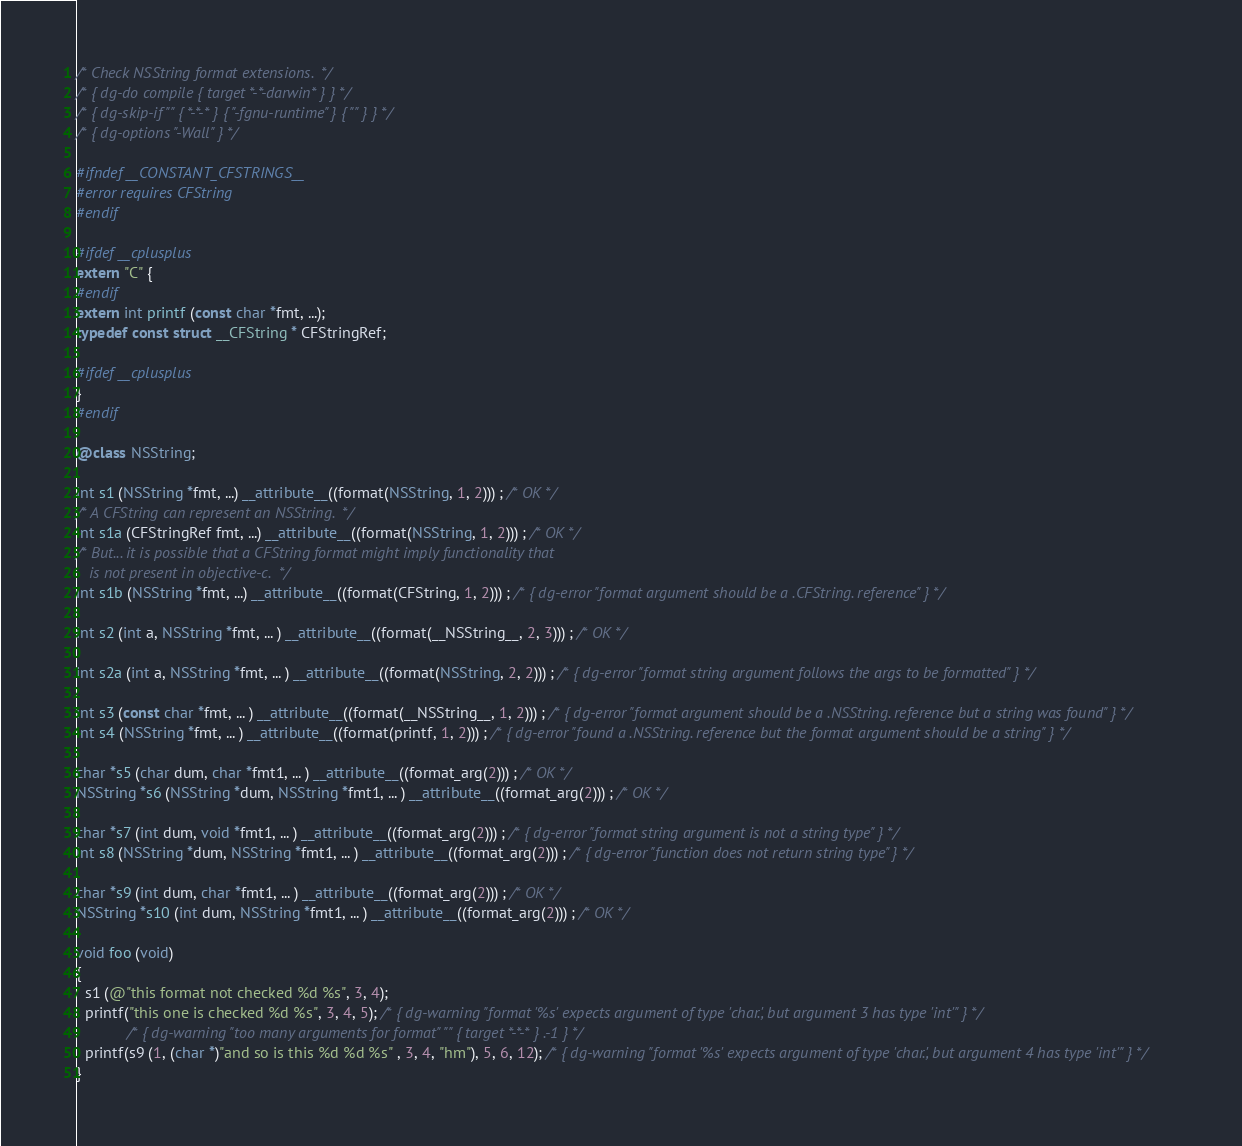Convert code to text. <code><loc_0><loc_0><loc_500><loc_500><_ObjectiveC_>/* Check NSString format extensions.  */
/* { dg-do compile { target *-*-darwin* } } */
/* { dg-skip-if "" { *-*-* } { "-fgnu-runtime" } { "" } } */
/* { dg-options "-Wall" } */

#ifndef __CONSTANT_CFSTRINGS__
#error requires CFString
#endif

#ifdef __cplusplus
extern "C" {
#endif
extern int printf (const char *fmt, ...);
typedef const struct __CFString * CFStringRef;

#ifdef __cplusplus
}
#endif

@class NSString;

int s1 (NSString *fmt, ...) __attribute__((format(NSString, 1, 2))) ; /* OK */
/* A CFString can represent an NSString.  */
int s1a (CFStringRef fmt, ...) __attribute__((format(NSString, 1, 2))) ; /* OK */
/* But... it is possible that a CFString format might imply functionality that
   is not present in objective-c.  */
int s1b (NSString *fmt, ...) __attribute__((format(CFString, 1, 2))) ; /* { dg-error "format argument should be a .CFString. reference" } */

int s2 (int a, NSString *fmt, ... ) __attribute__((format(__NSString__, 2, 3))) ; /* OK */

int s2a (int a, NSString *fmt, ... ) __attribute__((format(NSString, 2, 2))) ; /* { dg-error "format string argument follows the args to be formatted" } */

int s3 (const char *fmt, ... ) __attribute__((format(__NSString__, 1, 2))) ; /* { dg-error "format argument should be a .NSString. reference but a string was found" } */
int s4 (NSString *fmt, ... ) __attribute__((format(printf, 1, 2))) ; /* { dg-error "found a .NSString. reference but the format argument should be a string" } */

char *s5 (char dum, char *fmt1, ... ) __attribute__((format_arg(2))) ; /* OK */
NSString *s6 (NSString *dum, NSString *fmt1, ... ) __attribute__((format_arg(2))) ; /* OK */

char *s7 (int dum, void *fmt1, ... ) __attribute__((format_arg(2))) ; /* { dg-error "format string argument is not a string type" } */
int s8 (NSString *dum, NSString *fmt1, ... ) __attribute__((format_arg(2))) ; /* { dg-error "function does not return string type" } */

char *s9 (int dum, char *fmt1, ... ) __attribute__((format_arg(2))) ; /* OK */
NSString *s10 (int dum, NSString *fmt1, ... ) __attribute__((format_arg(2))) ; /* OK */

void foo (void)
{
  s1 (@"this format not checked %d %s", 3, 4);
  printf("this one is checked %d %s", 3, 4, 5); /* { dg-warning "format '%s' expects argument of type 'char.', but argument 3 has type 'int'" } */
			/* { dg-warning "too many arguments for format" "" { target *-*-* } .-1 } */
  printf(s9 (1, (char *)"and so is this %d %d %s" , 3, 4, "hm"), 5, 6, 12); /* { dg-warning "format '%s' expects argument of type 'char.', but argument 4 has type 'int'" } */
}
</code> 